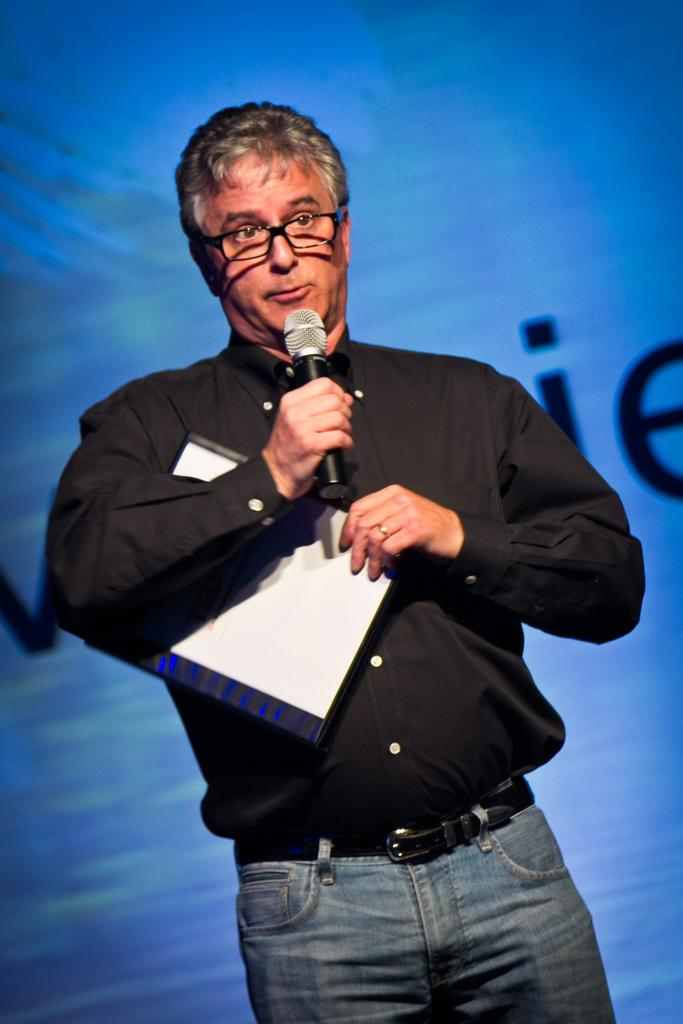Who is the main subject in the image? There is a man in the image. What is the man holding in the image? The man is holding a microphone. What accessory is the man wearing in the image? The man is wearing spectacles. What color is the shirt the man is wearing in the image? The man is wearing a black color shirt. What type of haircut does the man have in the image? The provided facts do not mention the man's haircut, so we cannot determine it from the image. 